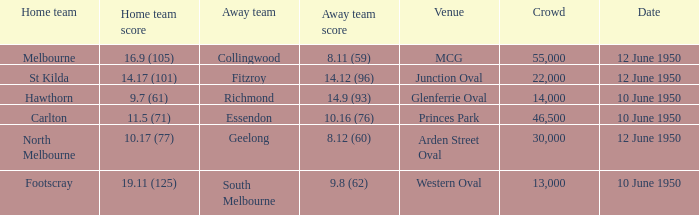Who was the away team when the VFL played at MCG? Collingwood. 